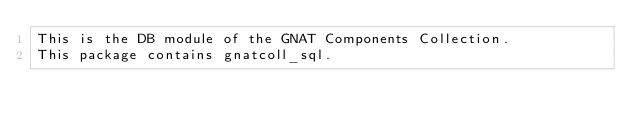<code> <loc_0><loc_0><loc_500><loc_500><_SQL_>This is the DB module of the GNAT Components Collection.
This package contains gnatcoll_sql.
</code> 